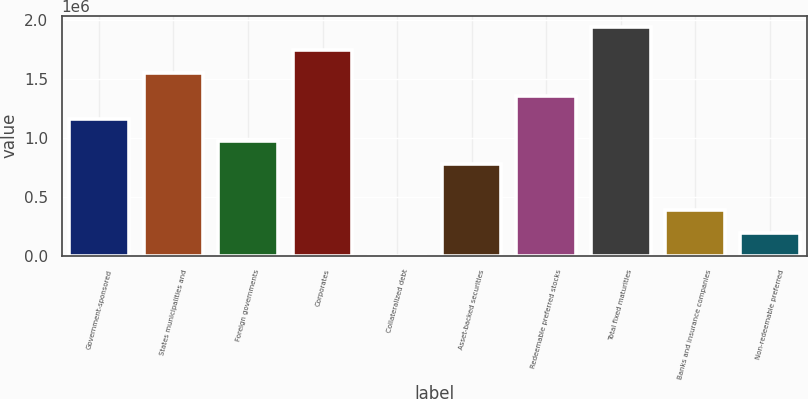Convert chart. <chart><loc_0><loc_0><loc_500><loc_500><bar_chart><fcel>Government-sponsored<fcel>States municipalities and<fcel>Foreign governments<fcel>Corporates<fcel>Collateralized debt<fcel>Asset-backed securities<fcel>Redeemable preferred stocks<fcel>Total fixed maturities<fcel>Banks and insurance companies<fcel>Non-redeemable preferred<nl><fcel>1.16173e+06<fcel>1.54897e+06<fcel>968110<fcel>1.7426e+06<fcel>2.18<fcel>774488<fcel>1.35535e+06<fcel>1.93622e+06<fcel>387245<fcel>193624<nl></chart> 